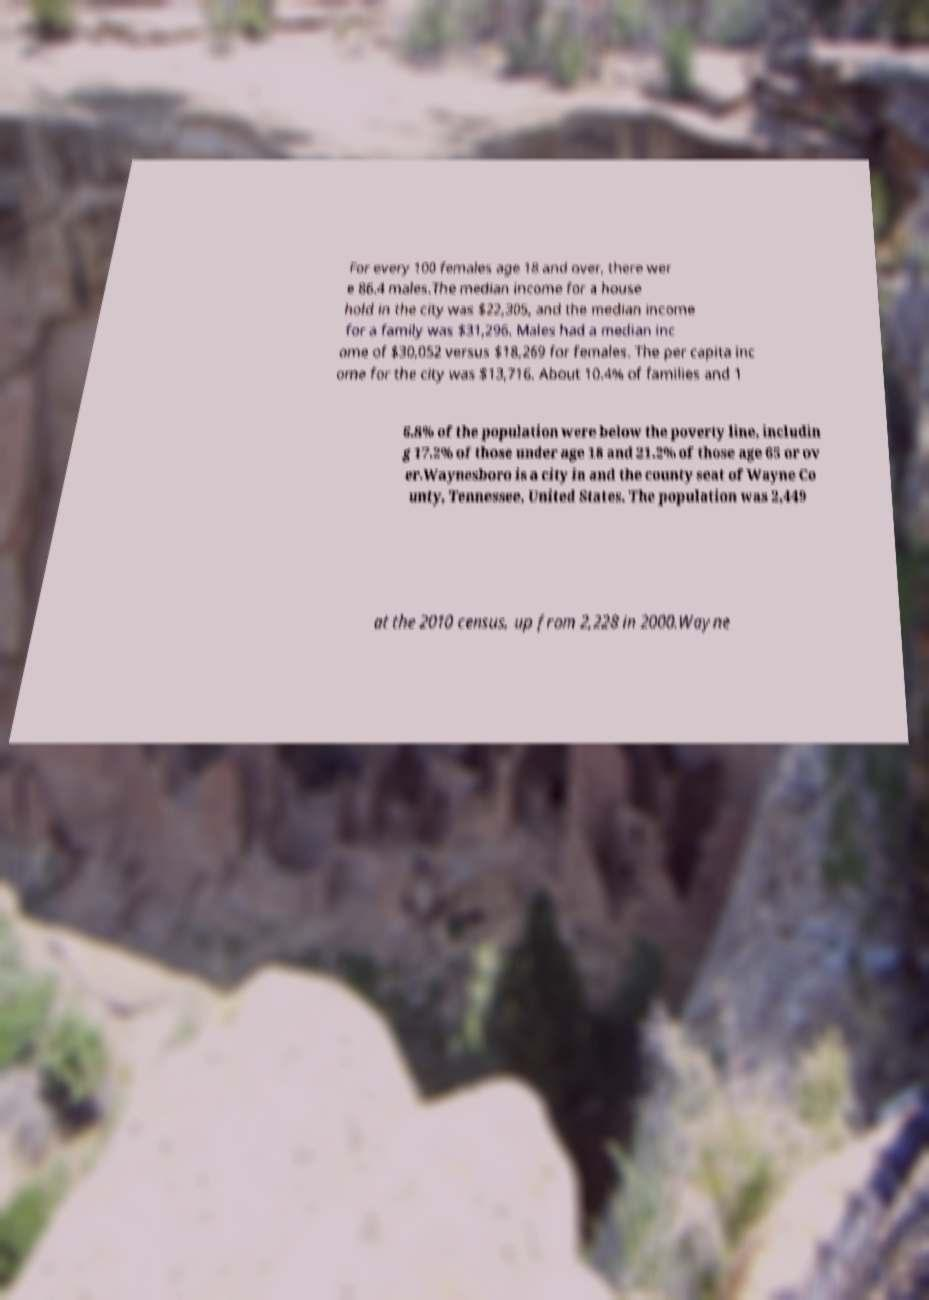Can you accurately transcribe the text from the provided image for me? For every 100 females age 18 and over, there wer e 86.4 males.The median income for a house hold in the city was $22,305, and the median income for a family was $31,296. Males had a median inc ome of $30,052 versus $18,269 for females. The per capita inc ome for the city was $13,716. About 10.4% of families and 1 6.8% of the population were below the poverty line, includin g 17.2% of those under age 18 and 21.2% of those age 65 or ov er.Waynesboro is a city in and the county seat of Wayne Co unty, Tennessee, United States. The population was 2,449 at the 2010 census, up from 2,228 in 2000.Wayne 